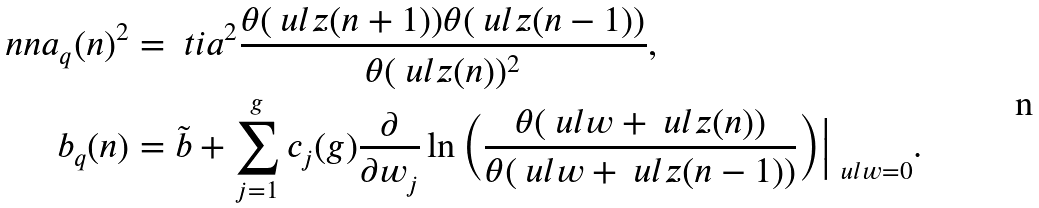<formula> <loc_0><loc_0><loc_500><loc_500>\ n n a _ { q } ( n ) ^ { 2 } & = \ t i { a } ^ { 2 } \frac { \theta ( \ u l z ( n + 1 ) ) \theta ( \ u l z ( n - 1 ) ) } { \theta ( \ u l z ( n ) ) ^ { 2 } } , \\ b _ { q } ( n ) & = \tilde { b } + \sum _ { j = 1 } ^ { g } c _ { j } ( g ) \frac { \partial } { \partial w _ { j } } \ln \Big ( \frac { \theta ( \ u l { w } + \ u l z ( n ) ) } { \theta ( \ u l { w } + \ u l z ( n - 1 ) ) } \Big ) \Big | _ { \ u l { w } = 0 } .</formula> 